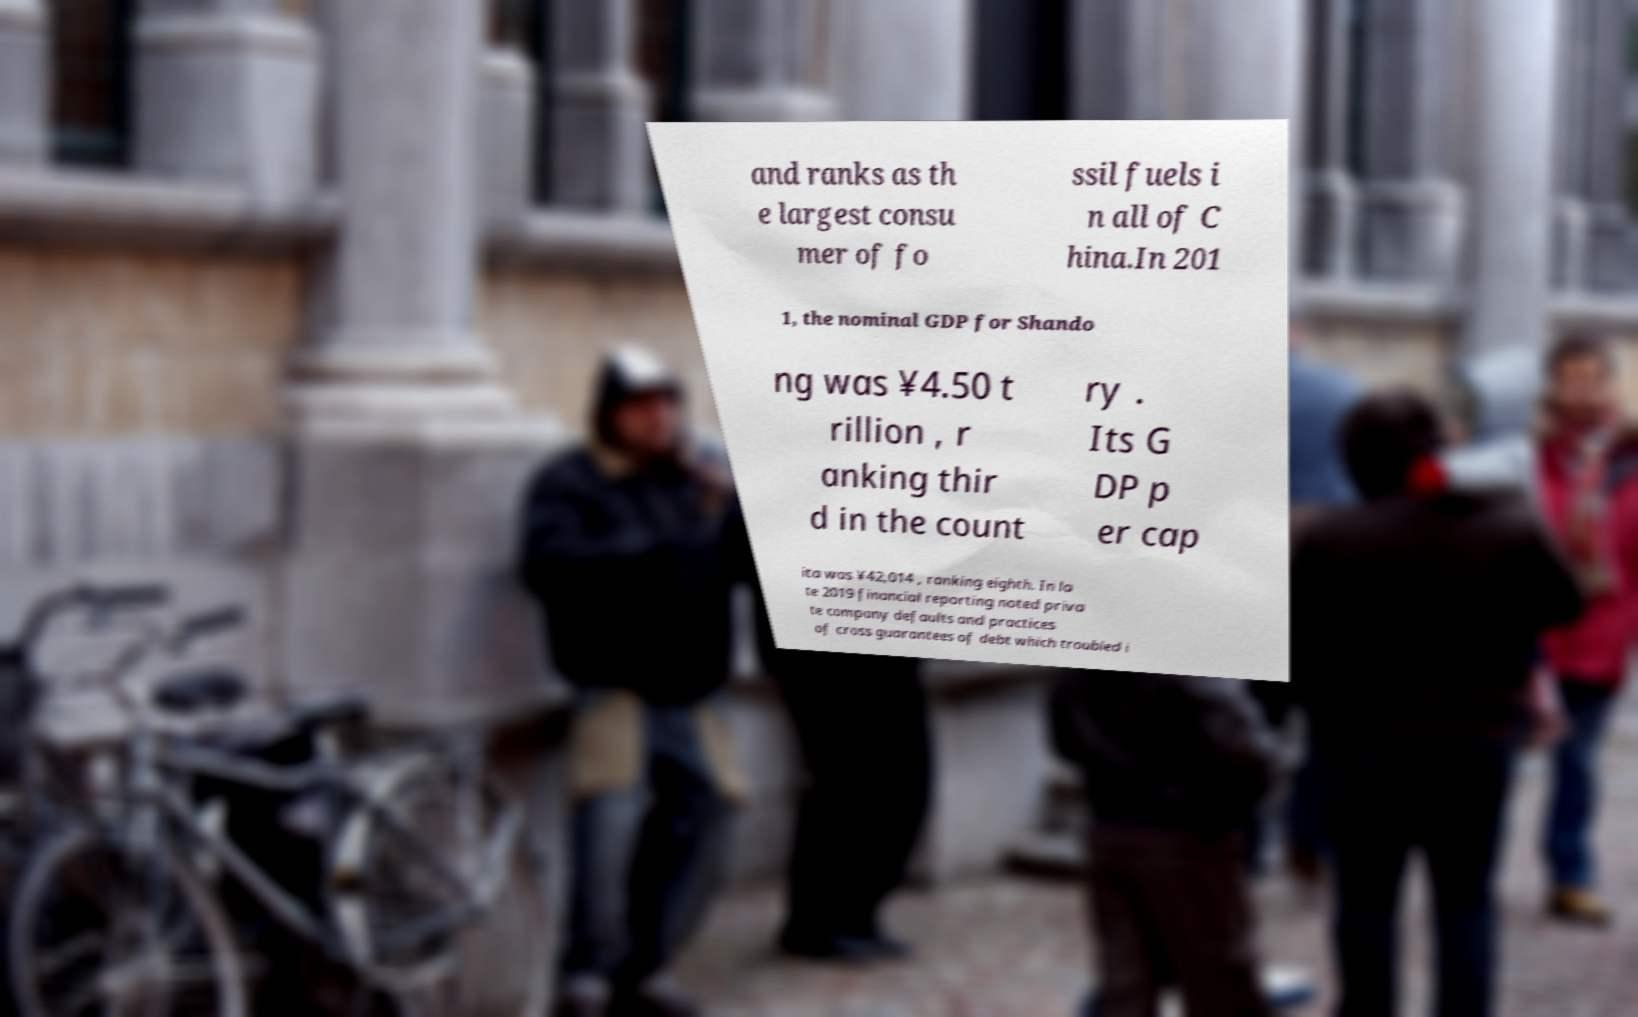Could you extract and type out the text from this image? and ranks as th e largest consu mer of fo ssil fuels i n all of C hina.In 201 1, the nominal GDP for Shando ng was ¥4.50 t rillion , r anking thir d in the count ry . Its G DP p er cap ita was ¥42,014 , ranking eighth. In la te 2019 financial reporting noted priva te company defaults and practices of cross guarantees of debt which troubled i 